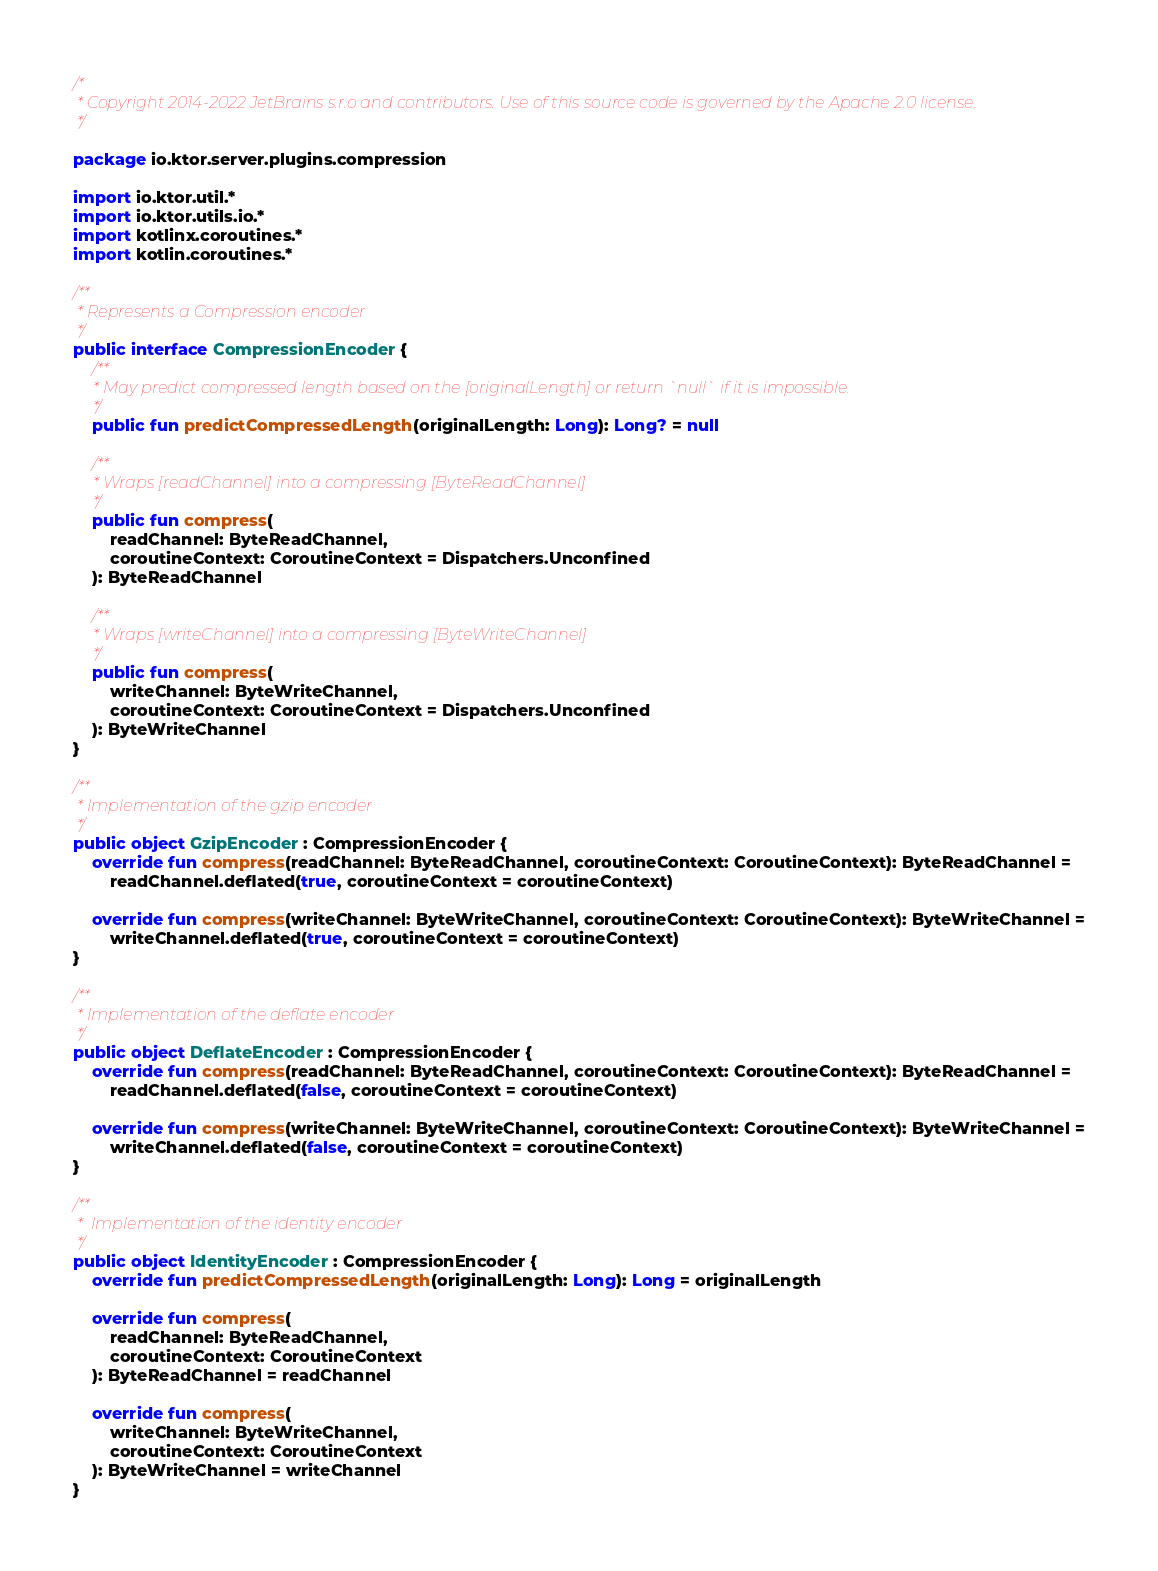Convert code to text. <code><loc_0><loc_0><loc_500><loc_500><_Kotlin_>/*
 * Copyright 2014-2022 JetBrains s.r.o and contributors. Use of this source code is governed by the Apache 2.0 license.
 */

package io.ktor.server.plugins.compression

import io.ktor.util.*
import io.ktor.utils.io.*
import kotlinx.coroutines.*
import kotlin.coroutines.*

/**
 * Represents a Compression encoder
 */
public interface CompressionEncoder {
    /**
     * May predict compressed length based on the [originalLength] or return `null` if it is impossible.
     */
    public fun predictCompressedLength(originalLength: Long): Long? = null

    /**
     * Wraps [readChannel] into a compressing [ByteReadChannel]
     */
    public fun compress(
        readChannel: ByteReadChannel,
        coroutineContext: CoroutineContext = Dispatchers.Unconfined
    ): ByteReadChannel

    /**
     * Wraps [writeChannel] into a compressing [ByteWriteChannel]
     */
    public fun compress(
        writeChannel: ByteWriteChannel,
        coroutineContext: CoroutineContext = Dispatchers.Unconfined
    ): ByteWriteChannel
}

/**
 * Implementation of the gzip encoder
 */
public object GzipEncoder : CompressionEncoder {
    override fun compress(readChannel: ByteReadChannel, coroutineContext: CoroutineContext): ByteReadChannel =
        readChannel.deflated(true, coroutineContext = coroutineContext)

    override fun compress(writeChannel: ByteWriteChannel, coroutineContext: CoroutineContext): ByteWriteChannel =
        writeChannel.deflated(true, coroutineContext = coroutineContext)
}

/**
 * Implementation of the deflate encoder
 */
public object DeflateEncoder : CompressionEncoder {
    override fun compress(readChannel: ByteReadChannel, coroutineContext: CoroutineContext): ByteReadChannel =
        readChannel.deflated(false, coroutineContext = coroutineContext)

    override fun compress(writeChannel: ByteWriteChannel, coroutineContext: CoroutineContext): ByteWriteChannel =
        writeChannel.deflated(false, coroutineContext = coroutineContext)
}

/**
 *  Implementation of the identity encoder
 */
public object IdentityEncoder : CompressionEncoder {
    override fun predictCompressedLength(originalLength: Long): Long = originalLength

    override fun compress(
        readChannel: ByteReadChannel,
        coroutineContext: CoroutineContext
    ): ByteReadChannel = readChannel

    override fun compress(
        writeChannel: ByteWriteChannel,
        coroutineContext: CoroutineContext
    ): ByteWriteChannel = writeChannel
}
</code> 